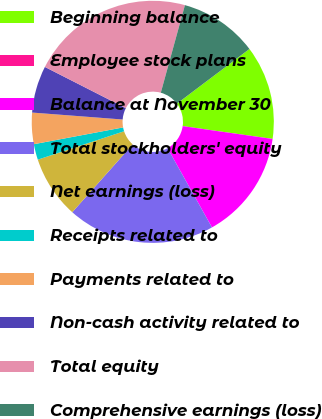<chart> <loc_0><loc_0><loc_500><loc_500><pie_chart><fcel>Beginning balance<fcel>Employee stock plans<fcel>Balance at November 30<fcel>Total stockholders' equity<fcel>Net earnings (loss)<fcel>Receipts related to<fcel>Payments related to<fcel>Non-cash activity related to<fcel>Total equity<fcel>Comprehensive earnings (loss)<nl><fcel>12.53%<fcel>0.01%<fcel>14.61%<fcel>19.71%<fcel>8.36%<fcel>2.1%<fcel>4.18%<fcel>6.27%<fcel>21.79%<fcel>10.44%<nl></chart> 